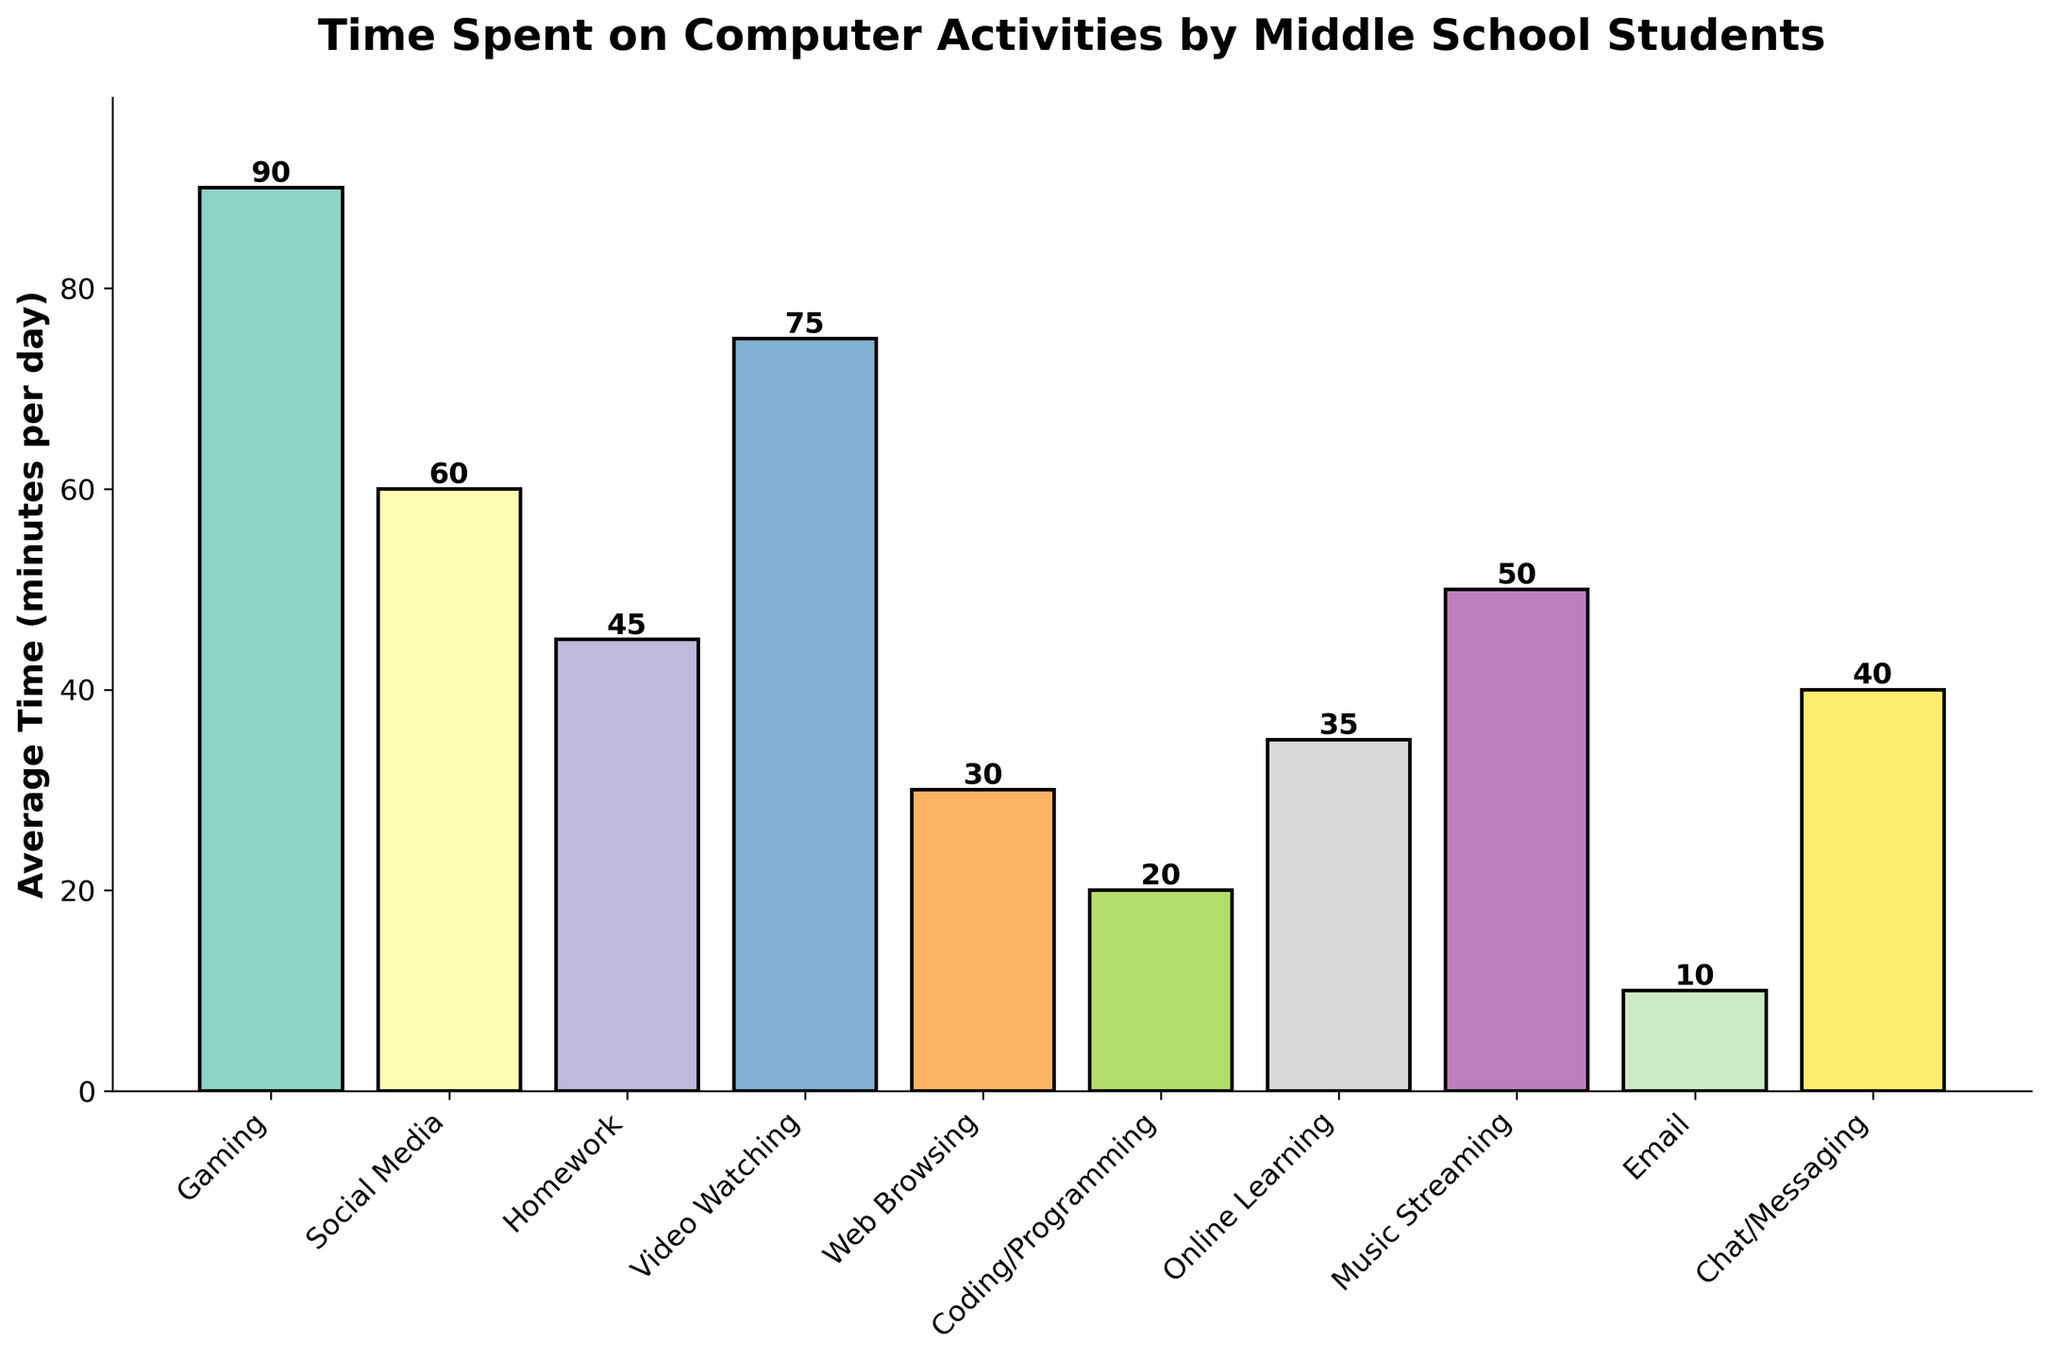What is the average time spent on Gaming and Social Media combined? First, find the time spent on Gaming (90 minutes) and on Social Media (60 minutes). Then, add the two values together: 90 + 60 = 150 minutes.
Answer: 150 minutes Which activity do middle school students spend the least time on? Look at the bars and identify the shortest bar, which represents the activity with the least time spent. The shortest bar corresponds to Email (10 minutes).
Answer: Email How much more time is spent on Video Watching compared to Web Browsing? First, find the time spent on Video Watching (75 minutes) and on Web Browsing (30 minutes). Then, subtract the time for Web Browsing from the time for Video Watching: 75 - 30 = 45 minutes.
Answer: 45 minutes Rank the top three activities in terms of time spent from highest to lowest. Identify the three tallest bars and the corresponding activities: Gaming (90 minutes), Video Watching (75 minutes), and Social Media (60 minutes).
Answer: Gaming, Video Watching, Social Media What is the difference in time spent between the activity with the highest average time and the activity with the lowest average time? First, identify the activity with the highest average time, which is Gaming (90 minutes), and the activity with the lowest average time, which is Email (10 minutes). Then, subtract the lowest from the highest: 90 - 10 = 80 minutes.
Answer: 80 minutes Which activities have an average time within the range of 40 to 60 minutes per day? Identify the bars that fall between 40 and 60 on the y-axis: Social Media (60 minutes), Homework (45 minutes), and Chat/Messaging (40 minutes).
Answer: Social Media, Homework, Chat/Messaging What is the combined average time spent on Online Learning, Music Streaming, and Coding/Programming? Find the average times for Online Learning (35 minutes), Music Streaming (50 minutes), and Coding/Programming (20 minutes). Add these times together: 35 + 50 + 20 = 105 minutes.
Answer: 105 minutes Is the average time spent on Homework greater than the average time spent on Web Browsing? Compare the heights of the bars for Homework (45 minutes) and Web Browsing (30 minutes). Since 45 is greater than 30, the answer is yes.
Answer: Yes 